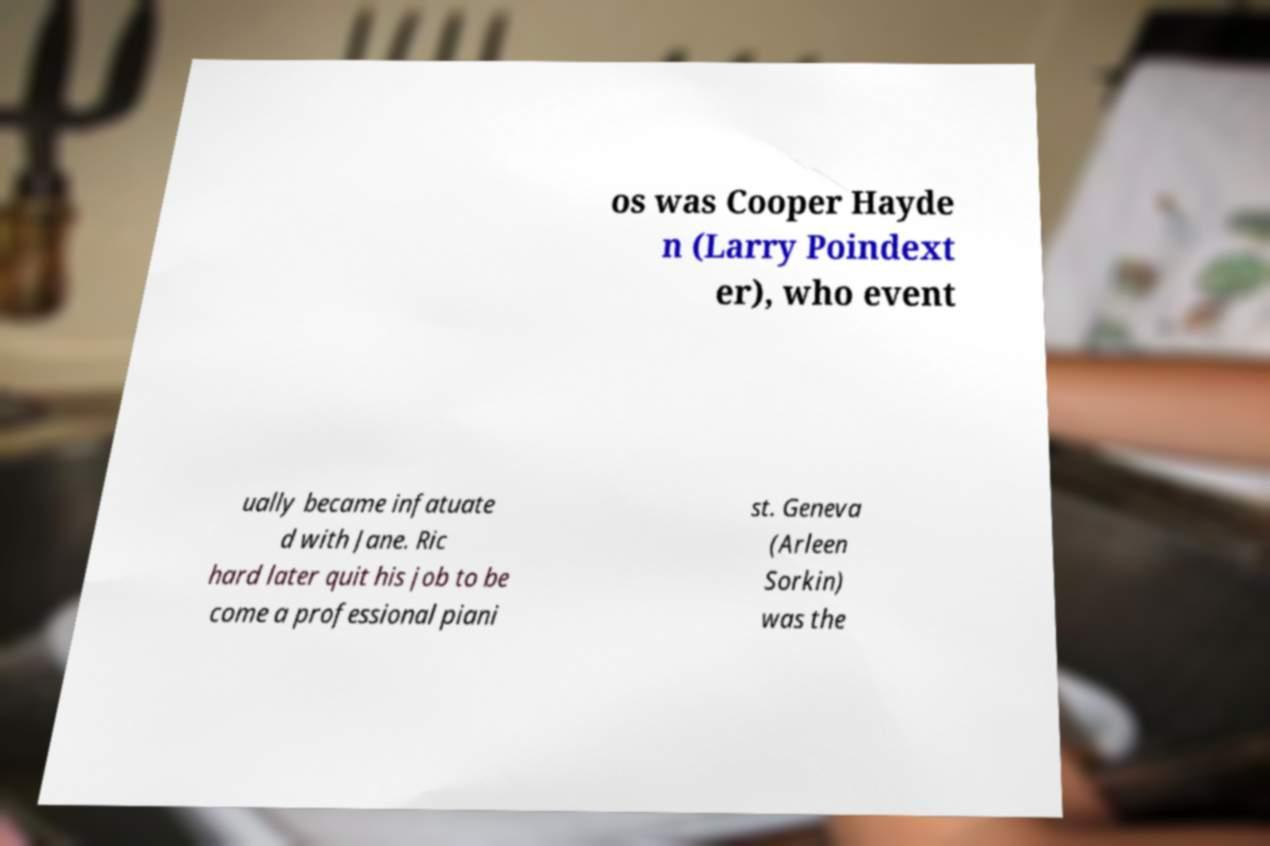Could you assist in decoding the text presented in this image and type it out clearly? os was Cooper Hayde n (Larry Poindext er), who event ually became infatuate d with Jane. Ric hard later quit his job to be come a professional piani st. Geneva (Arleen Sorkin) was the 